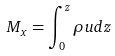<formula> <loc_0><loc_0><loc_500><loc_500>M _ { x } = \int _ { 0 } ^ { z } \rho u d z</formula> 